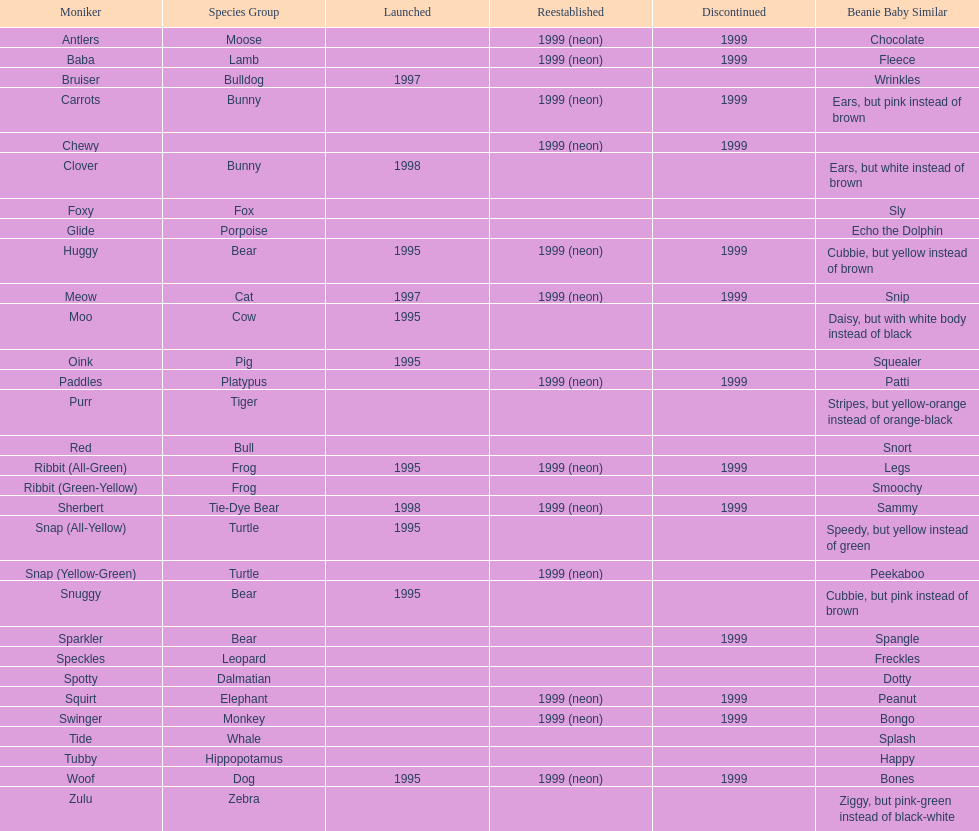What is the total number of pillow pals that were reintroduced as a neon variety? 13. I'm looking to parse the entire table for insights. Could you assist me with that? {'header': ['Moniker', 'Species Group', 'Launched', 'Reestablished', 'Discontinued', 'Beanie Baby Similar'], 'rows': [['Antlers', 'Moose', '', '1999 (neon)', '1999', 'Chocolate'], ['Baba', 'Lamb', '', '1999 (neon)', '1999', 'Fleece'], ['Bruiser', 'Bulldog', '1997', '', '', 'Wrinkles'], ['Carrots', 'Bunny', '', '1999 (neon)', '1999', 'Ears, but pink instead of brown'], ['Chewy', '', '', '1999 (neon)', '1999', ''], ['Clover', 'Bunny', '1998', '', '', 'Ears, but white instead of brown'], ['Foxy', 'Fox', '', '', '', 'Sly'], ['Glide', 'Porpoise', '', '', '', 'Echo the Dolphin'], ['Huggy', 'Bear', '1995', '1999 (neon)', '1999', 'Cubbie, but yellow instead of brown'], ['Meow', 'Cat', '1997', '1999 (neon)', '1999', 'Snip'], ['Moo', 'Cow', '1995', '', '', 'Daisy, but with white body instead of black'], ['Oink', 'Pig', '1995', '', '', 'Squealer'], ['Paddles', 'Platypus', '', '1999 (neon)', '1999', 'Patti'], ['Purr', 'Tiger', '', '', '', 'Stripes, but yellow-orange instead of orange-black'], ['Red', 'Bull', '', '', '', 'Snort'], ['Ribbit (All-Green)', 'Frog', '1995', '1999 (neon)', '1999', 'Legs'], ['Ribbit (Green-Yellow)', 'Frog', '', '', '', 'Smoochy'], ['Sherbert', 'Tie-Dye Bear', '1998', '1999 (neon)', '1999', 'Sammy'], ['Snap (All-Yellow)', 'Turtle', '1995', '', '', 'Speedy, but yellow instead of green'], ['Snap (Yellow-Green)', 'Turtle', '', '1999 (neon)', '', 'Peekaboo'], ['Snuggy', 'Bear', '1995', '', '', 'Cubbie, but pink instead of brown'], ['Sparkler', 'Bear', '', '', '1999', 'Spangle'], ['Speckles', 'Leopard', '', '', '', 'Freckles'], ['Spotty', 'Dalmatian', '', '', '', 'Dotty'], ['Squirt', 'Elephant', '', '1999 (neon)', '1999', 'Peanut'], ['Swinger', 'Monkey', '', '1999 (neon)', '1999', 'Bongo'], ['Tide', 'Whale', '', '', '', 'Splash'], ['Tubby', 'Hippopotamus', '', '', '', 'Happy'], ['Woof', 'Dog', '1995', '1999 (neon)', '1999', 'Bones'], ['Zulu', 'Zebra', '', '', '', 'Ziggy, but pink-green instead of black-white']]} 